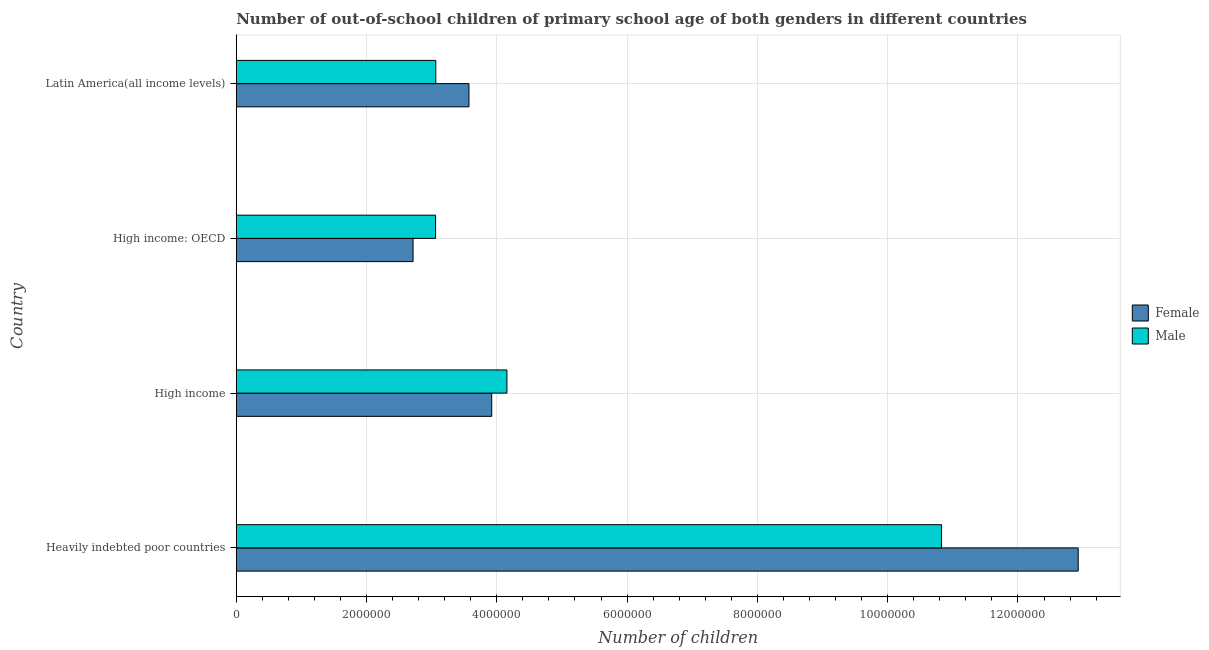How many different coloured bars are there?
Offer a very short reply. 2. How many groups of bars are there?
Keep it short and to the point. 4. Are the number of bars per tick equal to the number of legend labels?
Provide a short and direct response. Yes. Are the number of bars on each tick of the Y-axis equal?
Keep it short and to the point. Yes. How many bars are there on the 3rd tick from the top?
Make the answer very short. 2. In how many cases, is the number of bars for a given country not equal to the number of legend labels?
Give a very brief answer. 0. What is the number of male out-of-school students in Heavily indebted poor countries?
Your answer should be very brief. 1.08e+07. Across all countries, what is the maximum number of female out-of-school students?
Keep it short and to the point. 1.29e+07. Across all countries, what is the minimum number of male out-of-school students?
Give a very brief answer. 3.06e+06. In which country was the number of male out-of-school students maximum?
Offer a terse response. Heavily indebted poor countries. In which country was the number of female out-of-school students minimum?
Give a very brief answer. High income: OECD. What is the total number of female out-of-school students in the graph?
Your response must be concise. 2.31e+07. What is the difference between the number of female out-of-school students in High income and that in High income: OECD?
Offer a terse response. 1.21e+06. What is the difference between the number of male out-of-school students in Heavily indebted poor countries and the number of female out-of-school students in Latin America(all income levels)?
Your response must be concise. 7.25e+06. What is the average number of female out-of-school students per country?
Keep it short and to the point. 5.78e+06. What is the difference between the number of male out-of-school students and number of female out-of-school students in High income: OECD?
Your answer should be compact. 3.46e+05. What is the ratio of the number of female out-of-school students in Heavily indebted poor countries to that in High income: OECD?
Make the answer very short. 4.76. What is the difference between the highest and the second highest number of female out-of-school students?
Your answer should be compact. 9.00e+06. What is the difference between the highest and the lowest number of male out-of-school students?
Provide a succinct answer. 7.77e+06. In how many countries, is the number of female out-of-school students greater than the average number of female out-of-school students taken over all countries?
Keep it short and to the point. 1. Does the graph contain grids?
Ensure brevity in your answer.  Yes. Where does the legend appear in the graph?
Keep it short and to the point. Center right. How many legend labels are there?
Make the answer very short. 2. How are the legend labels stacked?
Your response must be concise. Vertical. What is the title of the graph?
Keep it short and to the point. Number of out-of-school children of primary school age of both genders in different countries. What is the label or title of the X-axis?
Provide a succinct answer. Number of children. What is the label or title of the Y-axis?
Your answer should be compact. Country. What is the Number of children of Female in Heavily indebted poor countries?
Ensure brevity in your answer.  1.29e+07. What is the Number of children of Male in Heavily indebted poor countries?
Offer a terse response. 1.08e+07. What is the Number of children of Female in High income?
Offer a very short reply. 3.92e+06. What is the Number of children in Male in High income?
Provide a short and direct response. 4.15e+06. What is the Number of children in Female in High income: OECD?
Provide a succinct answer. 2.71e+06. What is the Number of children of Male in High income: OECD?
Your response must be concise. 3.06e+06. What is the Number of children in Female in Latin America(all income levels)?
Provide a short and direct response. 3.57e+06. What is the Number of children in Male in Latin America(all income levels)?
Make the answer very short. 3.06e+06. Across all countries, what is the maximum Number of children in Female?
Your response must be concise. 1.29e+07. Across all countries, what is the maximum Number of children of Male?
Ensure brevity in your answer.  1.08e+07. Across all countries, what is the minimum Number of children of Female?
Provide a succinct answer. 2.71e+06. Across all countries, what is the minimum Number of children in Male?
Offer a very short reply. 3.06e+06. What is the total Number of children in Female in the graph?
Your answer should be very brief. 2.31e+07. What is the total Number of children of Male in the graph?
Provide a succinct answer. 2.11e+07. What is the difference between the Number of children in Female in Heavily indebted poor countries and that in High income?
Your answer should be compact. 9.00e+06. What is the difference between the Number of children of Male in Heavily indebted poor countries and that in High income?
Give a very brief answer. 6.67e+06. What is the difference between the Number of children in Female in Heavily indebted poor countries and that in High income: OECD?
Your answer should be very brief. 1.02e+07. What is the difference between the Number of children in Male in Heavily indebted poor countries and that in High income: OECD?
Ensure brevity in your answer.  7.77e+06. What is the difference between the Number of children in Female in Heavily indebted poor countries and that in Latin America(all income levels)?
Give a very brief answer. 9.35e+06. What is the difference between the Number of children of Male in Heavily indebted poor countries and that in Latin America(all income levels)?
Keep it short and to the point. 7.76e+06. What is the difference between the Number of children of Female in High income and that in High income: OECD?
Offer a very short reply. 1.21e+06. What is the difference between the Number of children in Male in High income and that in High income: OECD?
Ensure brevity in your answer.  1.09e+06. What is the difference between the Number of children in Female in High income and that in Latin America(all income levels)?
Provide a short and direct response. 3.49e+05. What is the difference between the Number of children of Male in High income and that in Latin America(all income levels)?
Make the answer very short. 1.09e+06. What is the difference between the Number of children in Female in High income: OECD and that in Latin America(all income levels)?
Your response must be concise. -8.58e+05. What is the difference between the Number of children of Male in High income: OECD and that in Latin America(all income levels)?
Make the answer very short. -3015. What is the difference between the Number of children of Female in Heavily indebted poor countries and the Number of children of Male in High income?
Offer a terse response. 8.77e+06. What is the difference between the Number of children in Female in Heavily indebted poor countries and the Number of children in Male in High income: OECD?
Keep it short and to the point. 9.86e+06. What is the difference between the Number of children in Female in Heavily indebted poor countries and the Number of children in Male in Latin America(all income levels)?
Ensure brevity in your answer.  9.86e+06. What is the difference between the Number of children of Female in High income and the Number of children of Male in High income: OECD?
Offer a very short reply. 8.61e+05. What is the difference between the Number of children in Female in High income and the Number of children in Male in Latin America(all income levels)?
Provide a short and direct response. 8.58e+05. What is the difference between the Number of children in Female in High income: OECD and the Number of children in Male in Latin America(all income levels)?
Make the answer very short. -3.49e+05. What is the average Number of children in Female per country?
Give a very brief answer. 5.78e+06. What is the average Number of children in Male per country?
Your response must be concise. 5.28e+06. What is the difference between the Number of children in Female and Number of children in Male in Heavily indebted poor countries?
Offer a terse response. 2.10e+06. What is the difference between the Number of children in Female and Number of children in Male in High income?
Ensure brevity in your answer.  -2.34e+05. What is the difference between the Number of children of Female and Number of children of Male in High income: OECD?
Keep it short and to the point. -3.46e+05. What is the difference between the Number of children of Female and Number of children of Male in Latin America(all income levels)?
Offer a terse response. 5.09e+05. What is the ratio of the Number of children of Female in Heavily indebted poor countries to that in High income?
Ensure brevity in your answer.  3.3. What is the ratio of the Number of children in Male in Heavily indebted poor countries to that in High income?
Provide a succinct answer. 2.61. What is the ratio of the Number of children in Female in Heavily indebted poor countries to that in High income: OECD?
Provide a succinct answer. 4.76. What is the ratio of the Number of children of Male in Heavily indebted poor countries to that in High income: OECD?
Your response must be concise. 3.54. What is the ratio of the Number of children of Female in Heavily indebted poor countries to that in Latin America(all income levels)?
Keep it short and to the point. 3.62. What is the ratio of the Number of children in Male in Heavily indebted poor countries to that in Latin America(all income levels)?
Provide a short and direct response. 3.53. What is the ratio of the Number of children of Female in High income to that in High income: OECD?
Provide a succinct answer. 1.44. What is the ratio of the Number of children of Male in High income to that in High income: OECD?
Offer a terse response. 1.36. What is the ratio of the Number of children in Female in High income to that in Latin America(all income levels)?
Your response must be concise. 1.1. What is the ratio of the Number of children in Male in High income to that in Latin America(all income levels)?
Your answer should be very brief. 1.36. What is the ratio of the Number of children in Female in High income: OECD to that in Latin America(all income levels)?
Your answer should be compact. 0.76. What is the ratio of the Number of children of Male in High income: OECD to that in Latin America(all income levels)?
Provide a short and direct response. 1. What is the difference between the highest and the second highest Number of children in Female?
Keep it short and to the point. 9.00e+06. What is the difference between the highest and the second highest Number of children of Male?
Keep it short and to the point. 6.67e+06. What is the difference between the highest and the lowest Number of children in Female?
Offer a terse response. 1.02e+07. What is the difference between the highest and the lowest Number of children of Male?
Make the answer very short. 7.77e+06. 